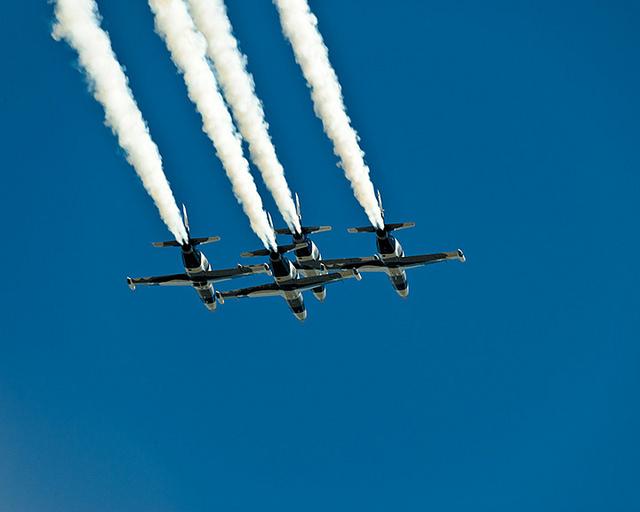Are these commercial planes?
Concise answer only. No. Are the planes in motion?
Concise answer only. Yes. How many items are in the sky?
Keep it brief. 4. What is trailing behind the airplanes?
Answer briefly. Smoke. Are all the planes flying in the same direction?
Write a very short answer. Yes. What flying team is this?
Concise answer only. Blue angels. Are all of the planes making a contrail?
Short answer required. Yes. How many planes are in the air?
Short answer required. 4. 